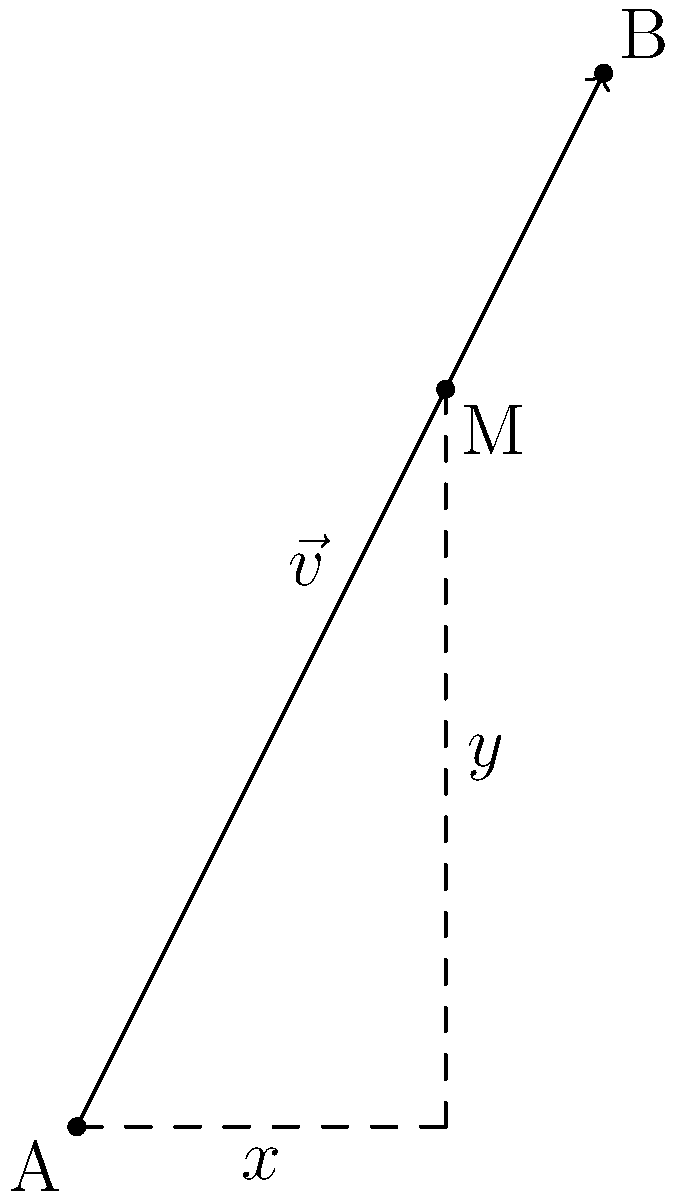As a DJ, you're analyzing the movement of your turntable's tonearm. The arm moves from point A (0,0) to point B (2,4) in 0.5 seconds. Calculate the velocity vector $\vec{v}$ of the tonearm's movement. To find the velocity vector, we need to follow these steps:

1) First, let's determine the displacement vector $\vec{d}$:
   $\vec{d} = \vec{B} - \vec{A} = (2,4) - (0,0) = (2,4)$

2) The velocity vector $\vec{v}$ is defined as the displacement vector divided by the time taken:
   $\vec{v} = \frac{\vec{d}}{t}$

3) We know that $t = 0.5$ seconds, so:
   $\vec{v} = \frac{(2,4)}{0.5}$

4) Dividing both components by 0.5:
   $\vec{v} = (2 \div 0.5, 4 \div 0.5) = (4,8)$

Therefore, the velocity vector $\vec{v}$ is $(4,8)$ units per second.
Answer: $(4,8)$ units/s 